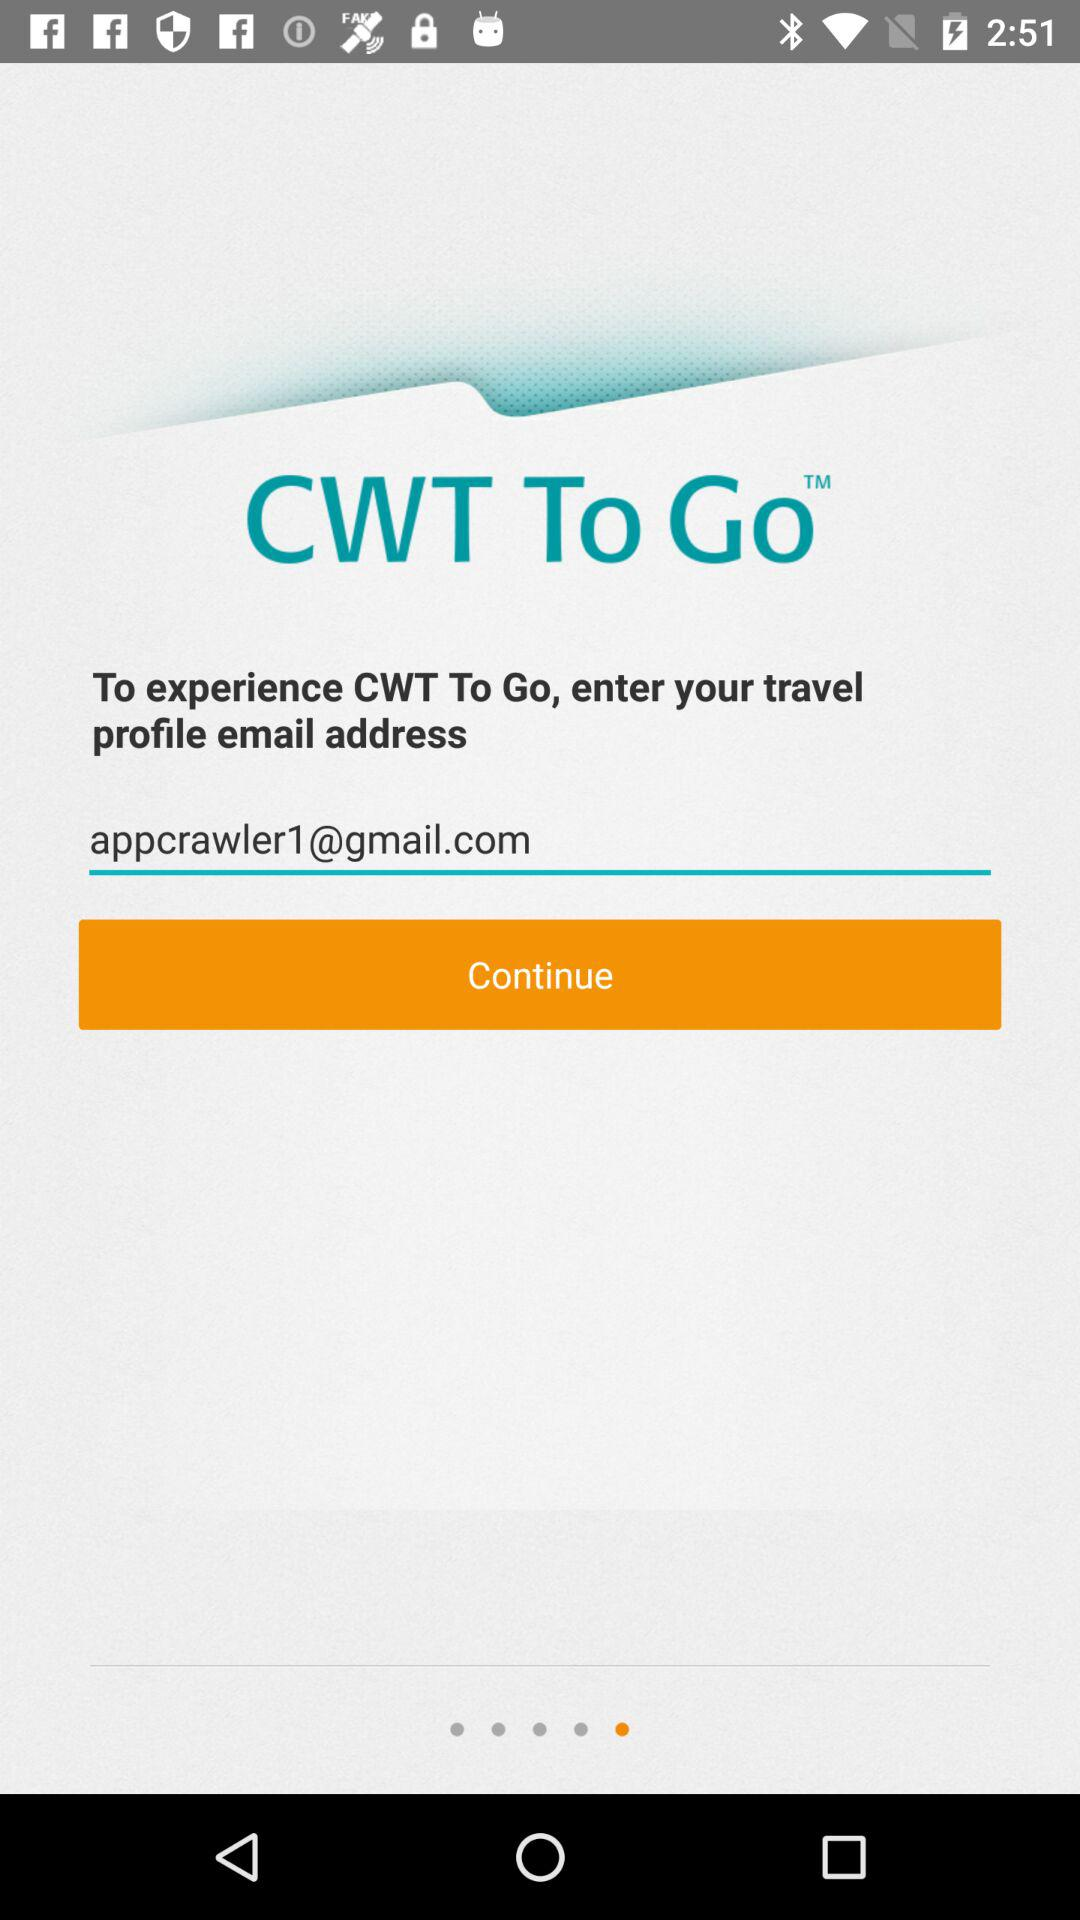What is the email address? The email address is appcrawler1@gmail.com. 